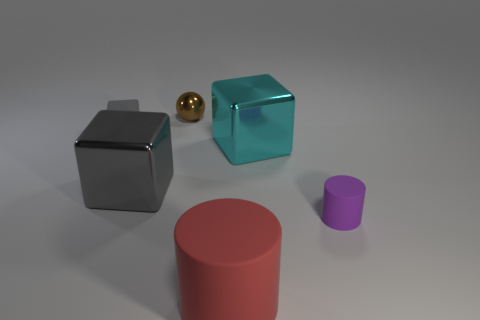There is another shiny object that is the same shape as the cyan metallic object; what color is it?
Offer a very short reply. Gray. Are there more cubes left of the gray metal block than big brown rubber spheres?
Your answer should be very brief. Yes. How many small purple cylinders are in front of the gray object that is to the right of the matte thing that is on the left side of the red matte object?
Your response must be concise. 1. There is a large thing that is right of the shiny sphere and behind the red cylinder; what is its material?
Your response must be concise. Metal. The large rubber cylinder has what color?
Give a very brief answer. Red. Are there more large gray shiny things that are right of the tiny block than tiny matte cylinders in front of the purple matte thing?
Ensure brevity in your answer.  Yes. The matte thing that is behind the purple matte cylinder is what color?
Keep it short and to the point. Gray. Do the metal thing right of the tiny brown ball and the metallic cube left of the red rubber object have the same size?
Your answer should be very brief. Yes. How many objects are either tiny brown rubber blocks or brown balls?
Your answer should be very brief. 1. There is a gray object that is in front of the large cube on the right side of the brown metallic object; what is its material?
Offer a terse response. Metal. 